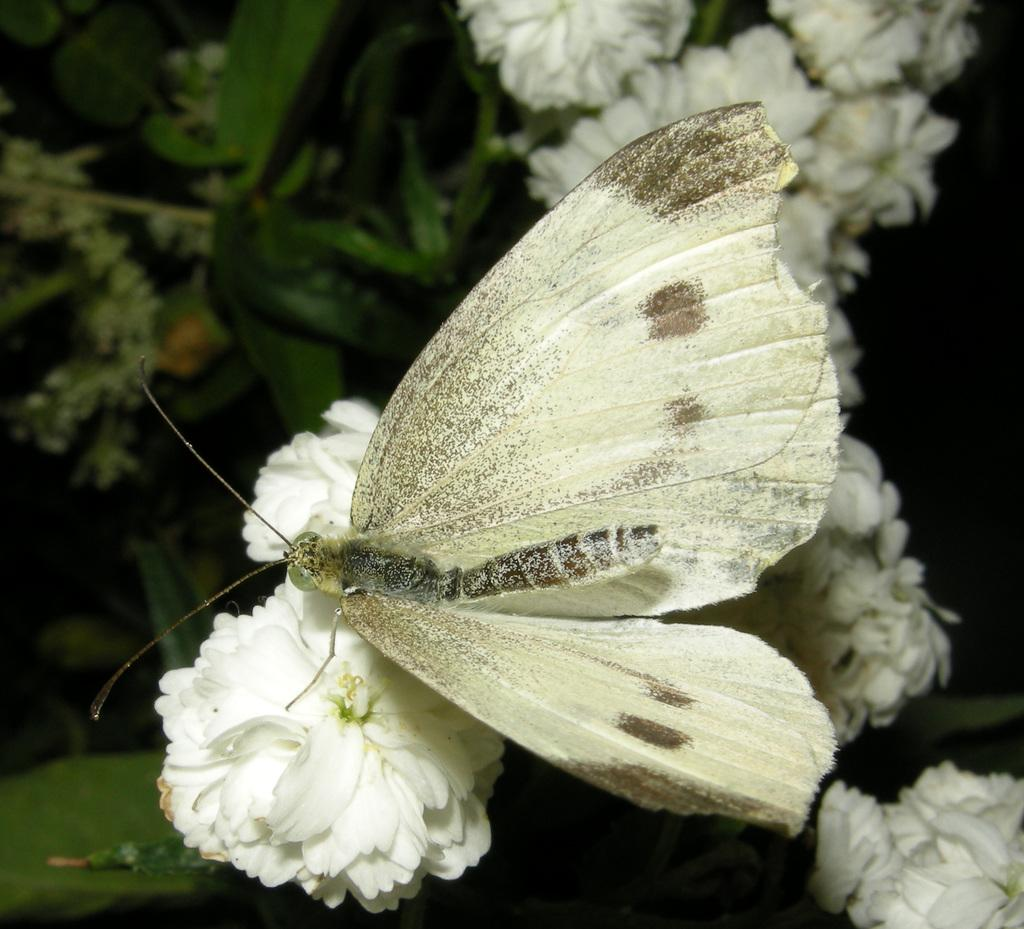What types of living organisms can be seen in the image? There are many plants in the image, including flowers. What is the relationship between the plants and the flowers in the image? The flowers are on the plants in the image. Can you describe any additional details about the image? There is a butterfly sitting on a flower in the image. What type of crime is being committed in the image? There is no crime present in the image; it features plants, flowers, and a butterfly. Are there any bears visible in the image? There are no bears present in the image. 